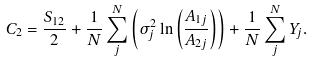<formula> <loc_0><loc_0><loc_500><loc_500>C _ { 2 } = \frac { S _ { 1 2 } } { 2 } + \frac { 1 } { N } \sum ^ { N } _ { j } \left ( \sigma _ { j } ^ { 2 } \ln \left ( \frac { A _ { 1 j } } { A _ { 2 j } } \right ) \right ) + \frac { 1 } { N } \sum ^ { N } _ { j } Y _ { j } .</formula> 